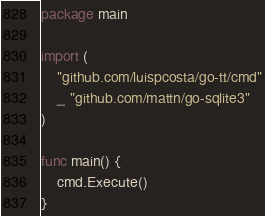<code> <loc_0><loc_0><loc_500><loc_500><_Go_>package main

import (
	"github.com/luispcosta/go-tt/cmd"
	_ "github.com/mattn/go-sqlite3"
)

func main() {
	cmd.Execute()
}
</code> 